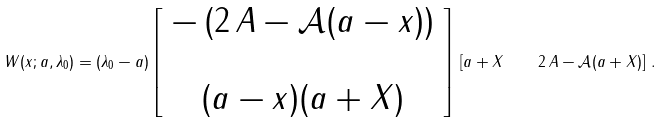Convert formula to latex. <formula><loc_0><loc_0><loc_500><loc_500>W ( x ; a , \lambda _ { 0 } ) = ( \lambda _ { 0 } - a ) \left [ \begin{array} { c } - \left ( 2 \, A - \mathcal { A } ( a - x ) \right ) \\ \\ ( a - x ) ( a + X ) \end{array} \right ] \, \left [ a + X \quad 2 \, A - \mathcal { A } ( a + X ) \right ] \, .</formula> 